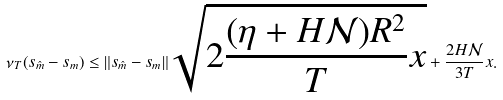<formula> <loc_0><loc_0><loc_500><loc_500>\nu _ { T } ( s _ { \hat { m } } - s _ { m } ) \leq \| s _ { \hat { m } } - s _ { m } \| \sqrt { 2 \frac { ( \eta + H \mathcal { N } ) R ^ { 2 } } { T } x } + \frac { 2 H \mathcal { N } } { 3 T } x .</formula> 